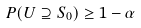<formula> <loc_0><loc_0><loc_500><loc_500>P ( U \supseteq S _ { 0 } ) \geq 1 - \alpha</formula> 